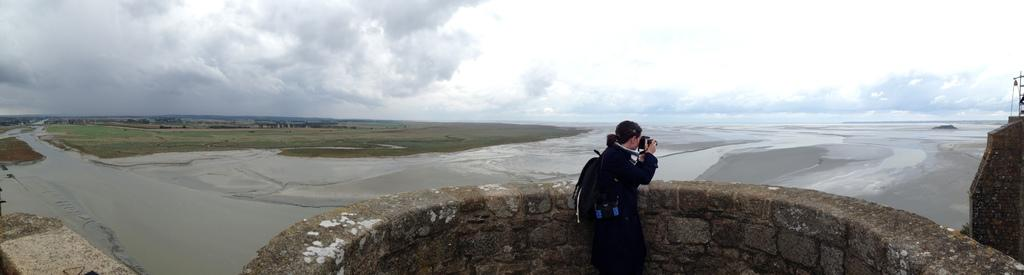What is the main subject of the picture? The main subject of the picture is a man. Where is the man located in the image? The man is standing near a wall in the image. What is the man doing in the picture? The man is capturing pictures in the image. What type of scenery is the man capturing pictures of? The man is capturing pictures of rivers and grass surfaces. What is visible in the background of the image? There is a sky visible in the background of the image. What can be seen in the sky? Clouds are present in the sky. Can you tell me how many squirrels are climbing the wall in the image? There are no squirrels climbing the wall in the image. What type of rod is the man using to capture pictures in the image? The man is not using a rod to capture pictures in the image; he is likely using a camera. 